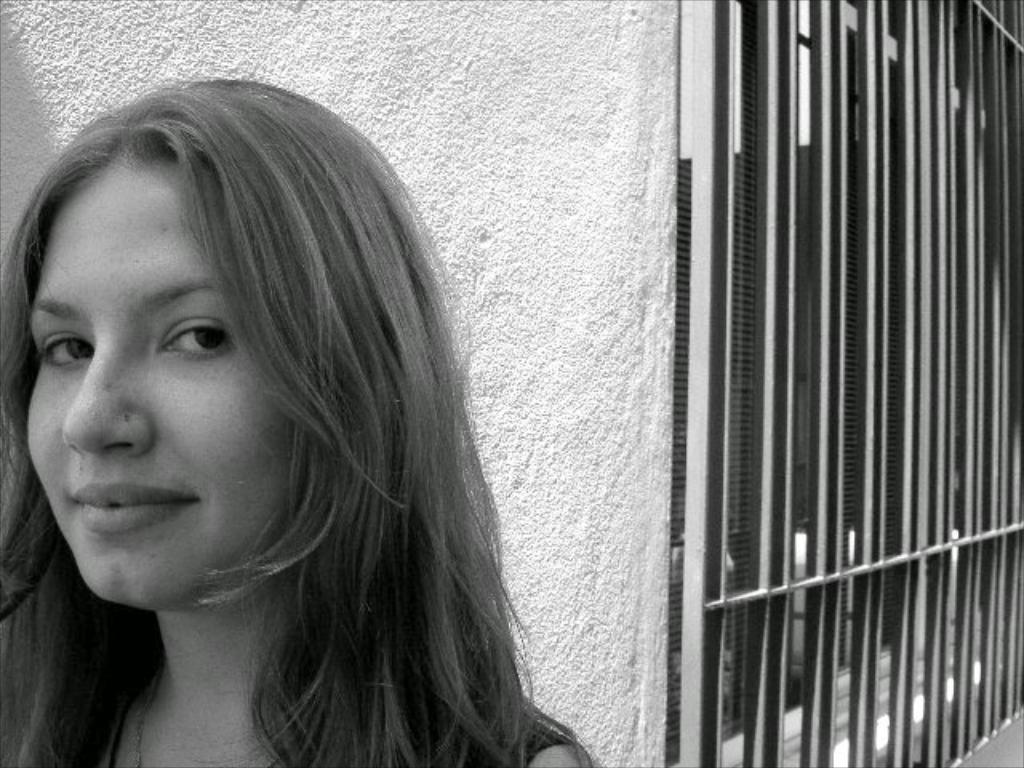In one or two sentences, can you explain what this image depicts? In this image I can see a woman and a wall in the background. 